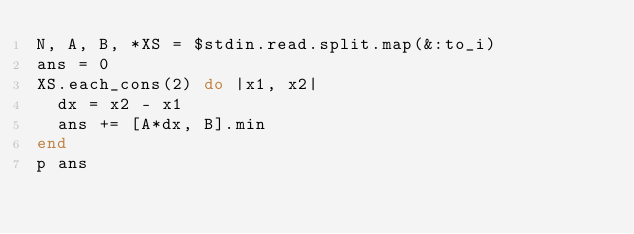<code> <loc_0><loc_0><loc_500><loc_500><_Ruby_>N, A, B, *XS = $stdin.read.split.map(&:to_i)
ans = 0
XS.each_cons(2) do |x1, x2|
  dx = x2 - x1
  ans += [A*dx, B].min
end
p ans
</code> 